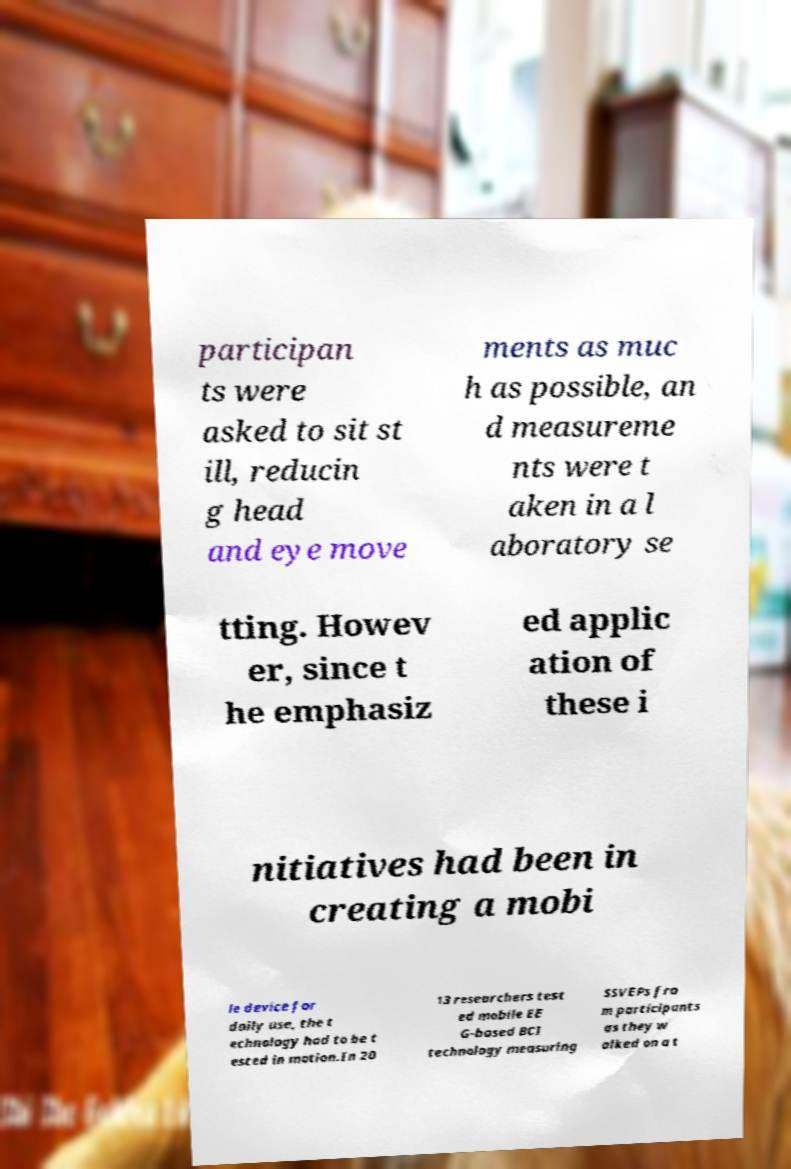Could you assist in decoding the text presented in this image and type it out clearly? participan ts were asked to sit st ill, reducin g head and eye move ments as muc h as possible, an d measureme nts were t aken in a l aboratory se tting. Howev er, since t he emphasiz ed applic ation of these i nitiatives had been in creating a mobi le device for daily use, the t echnology had to be t ested in motion.In 20 13 researchers test ed mobile EE G-based BCI technology measuring SSVEPs fro m participants as they w alked on a t 